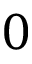Convert formula to latex. <formula><loc_0><loc_0><loc_500><loc_500>0</formula> 